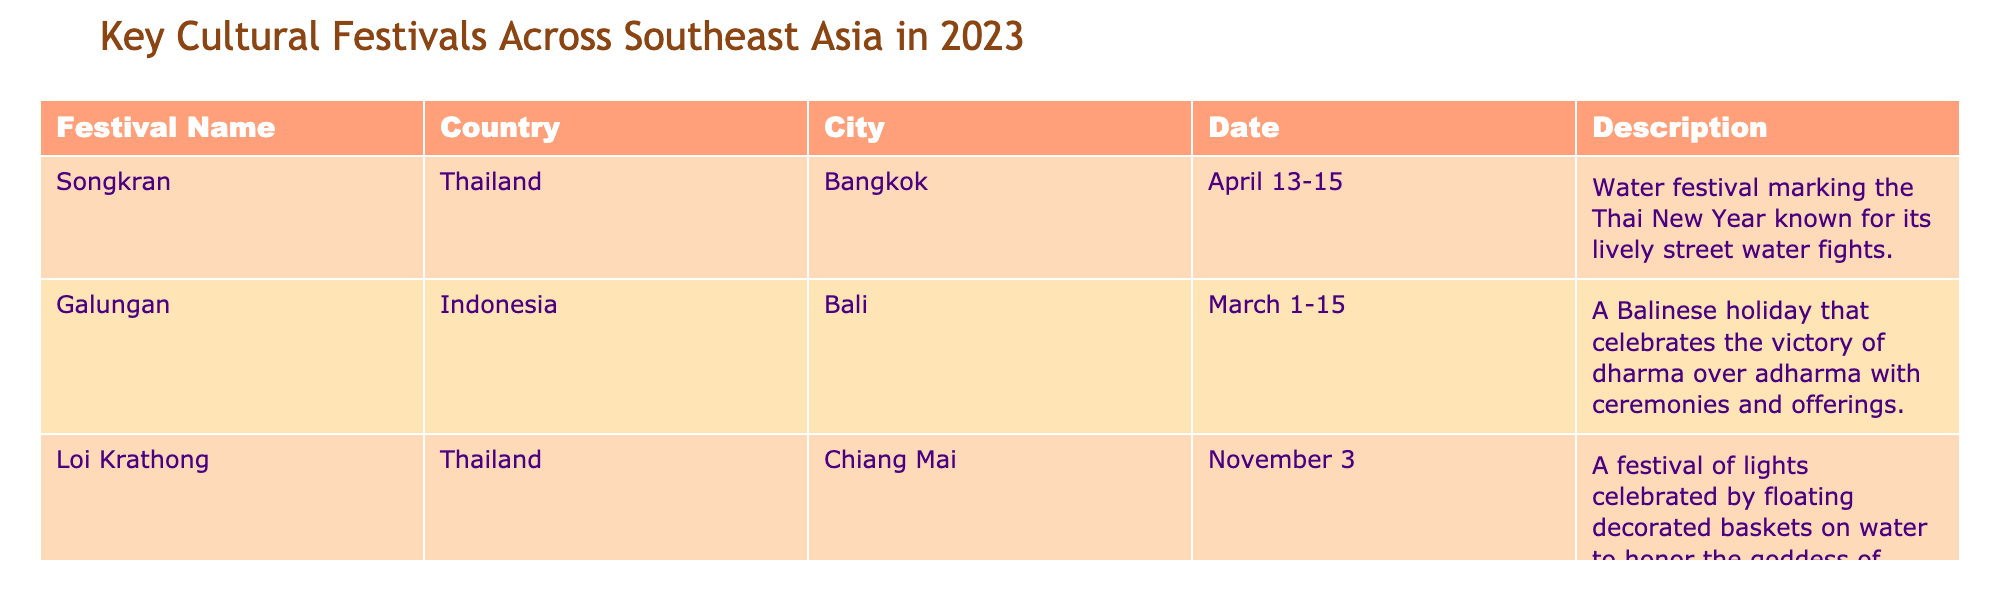What is the date of the Songkran festival in Thailand? The table shows that the Songkran festival is celebrated from April 13 to April 15 in Thailand.
Answer: April 13-15 Which festival takes place in Bali, Indonesia? Referring to the table, the festival listed for Bali, Indonesia is Galungan.
Answer: Galungan How many cultural festivals are listed in the table? There are three cultural festivals mentioned in the table: Songkran, Galungan, and Loi Krathong.
Answer: 3 What month does the Loi Krathong festival occur? According to the table, Loi Krathong is celebrated in November.
Answer: November Is the description of Songkran focused on traditional ceremonies? The description of Songkran emphasizes water fights, not traditional ceremonies. Therefore, the answer is no.
Answer: No Which festival celebrates the victory of dharma over adharma? The table indicates that Galungan celebrates the victory of dharma over adharma with ceremonies and offerings.
Answer: Galungan How many days does the Songkran festival last? Songkran lasts for three days, as it is celebrated from April 13 to April 15.
Answer: 3 days Which festival is celebrated in Chiang Mai, Thailand? The table states that Loi Krathong is celebrated in Chiang Mai, Thailand.
Answer: Loi Krathong Is there a festival that involves floating decorated baskets on water? The description for Loi Krathong mentions floating decorated baskets on water, indicating that yes, there is such a festival.
Answer: Yes What is the difference in months between Galungan and Loi Krathong? Galungan occurs in March, and Loi Krathong in November, with the difference being 8 months (March to November).
Answer: 8 months 